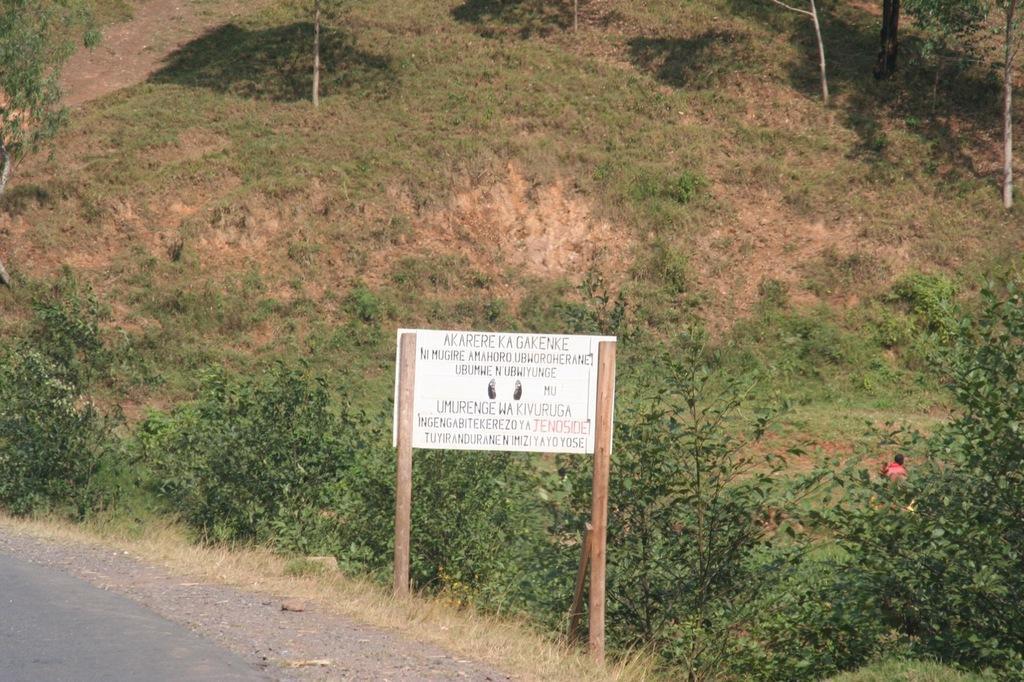Could you give a brief overview of what you see in this image? This is a board, which is attached to the wooden poles. I think this is a hill. I can see the grass. These are the small trees. This is the dried grass. I think this is a road. 